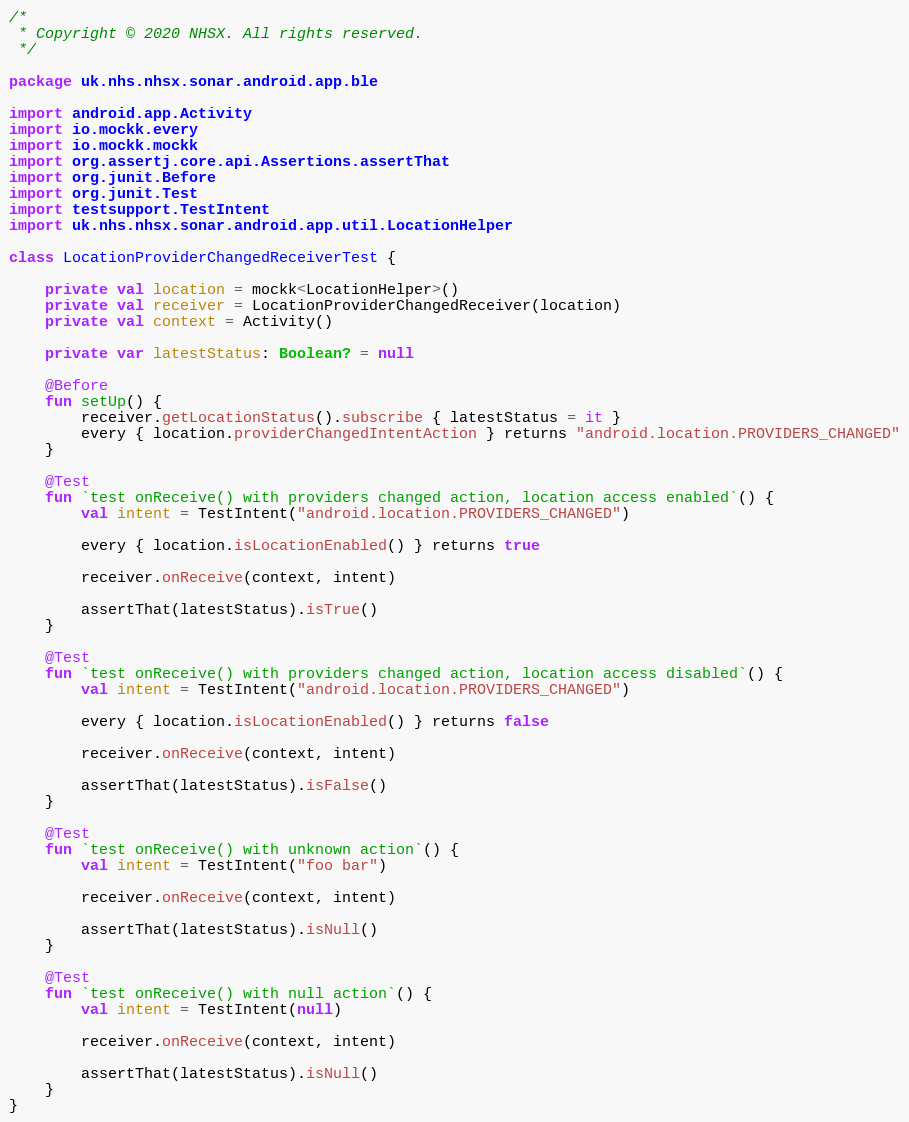Convert code to text. <code><loc_0><loc_0><loc_500><loc_500><_Kotlin_>/*
 * Copyright © 2020 NHSX. All rights reserved.
 */

package uk.nhs.nhsx.sonar.android.app.ble

import android.app.Activity
import io.mockk.every
import io.mockk.mockk
import org.assertj.core.api.Assertions.assertThat
import org.junit.Before
import org.junit.Test
import testsupport.TestIntent
import uk.nhs.nhsx.sonar.android.app.util.LocationHelper

class LocationProviderChangedReceiverTest {

    private val location = mockk<LocationHelper>()
    private val receiver = LocationProviderChangedReceiver(location)
    private val context = Activity()

    private var latestStatus: Boolean? = null

    @Before
    fun setUp() {
        receiver.getLocationStatus().subscribe { latestStatus = it }
        every { location.providerChangedIntentAction } returns "android.location.PROVIDERS_CHANGED"
    }

    @Test
    fun `test onReceive() with providers changed action, location access enabled`() {
        val intent = TestIntent("android.location.PROVIDERS_CHANGED")

        every { location.isLocationEnabled() } returns true

        receiver.onReceive(context, intent)

        assertThat(latestStatus).isTrue()
    }

    @Test
    fun `test onReceive() with providers changed action, location access disabled`() {
        val intent = TestIntent("android.location.PROVIDERS_CHANGED")

        every { location.isLocationEnabled() } returns false

        receiver.onReceive(context, intent)

        assertThat(latestStatus).isFalse()
    }

    @Test
    fun `test onReceive() with unknown action`() {
        val intent = TestIntent("foo bar")

        receiver.onReceive(context, intent)

        assertThat(latestStatus).isNull()
    }

    @Test
    fun `test onReceive() with null action`() {
        val intent = TestIntent(null)

        receiver.onReceive(context, intent)

        assertThat(latestStatus).isNull()
    }
}
</code> 